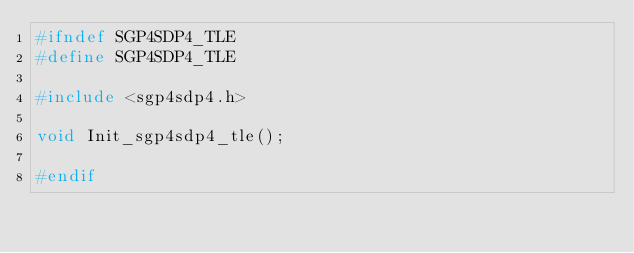Convert code to text. <code><loc_0><loc_0><loc_500><loc_500><_C_>#ifndef SGP4SDP4_TLE
#define SGP4SDP4_TLE

#include <sgp4sdp4.h>

void Init_sgp4sdp4_tle();

#endif
</code> 